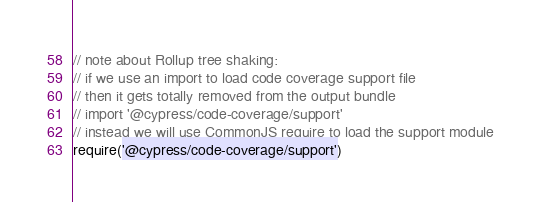Convert code to text. <code><loc_0><loc_0><loc_500><loc_500><_JavaScript_>// note about Rollup tree shaking:
// if we use an import to load code coverage support file
// then it gets totally removed from the output bundle
// import '@cypress/code-coverage/support'
// instead we will use CommonJS require to load the support module
require('@cypress/code-coverage/support')
</code> 